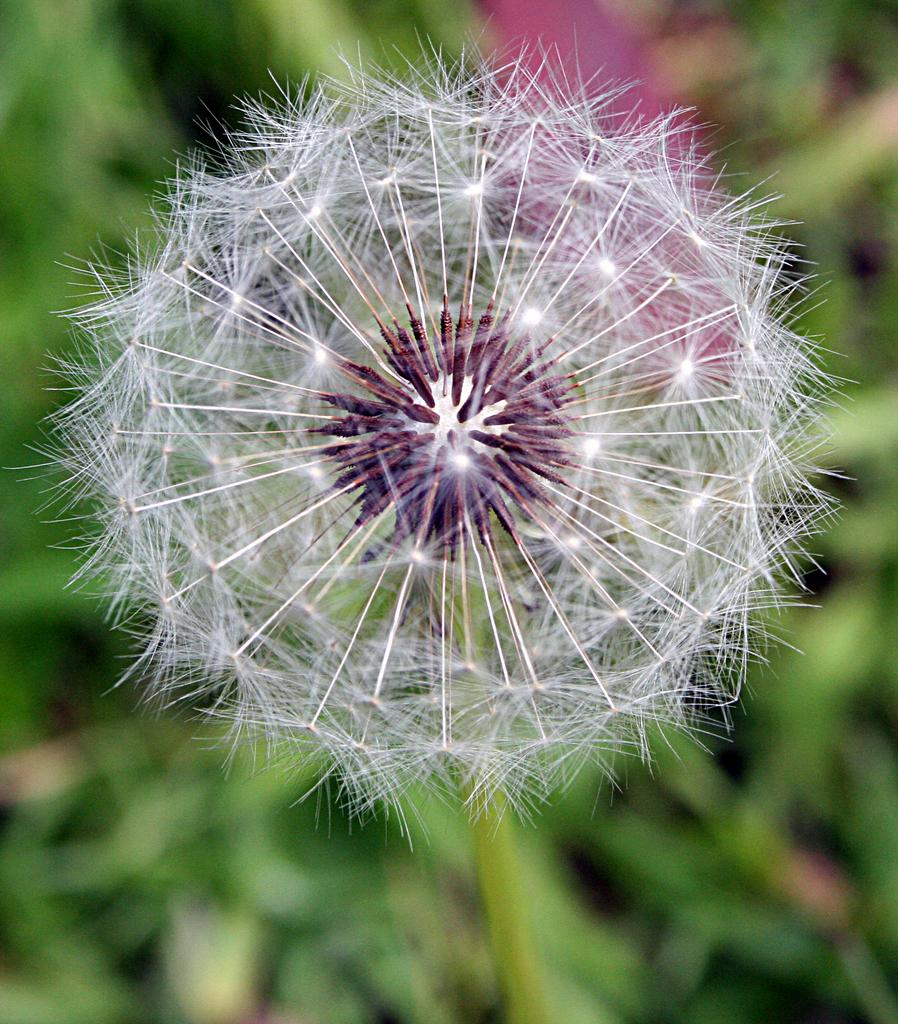What is the main subject of the image? There is a flower in the image. What type of comb is being used to style the flower in the image? There is no comb present in the image, as it features a flower and nothing else. 